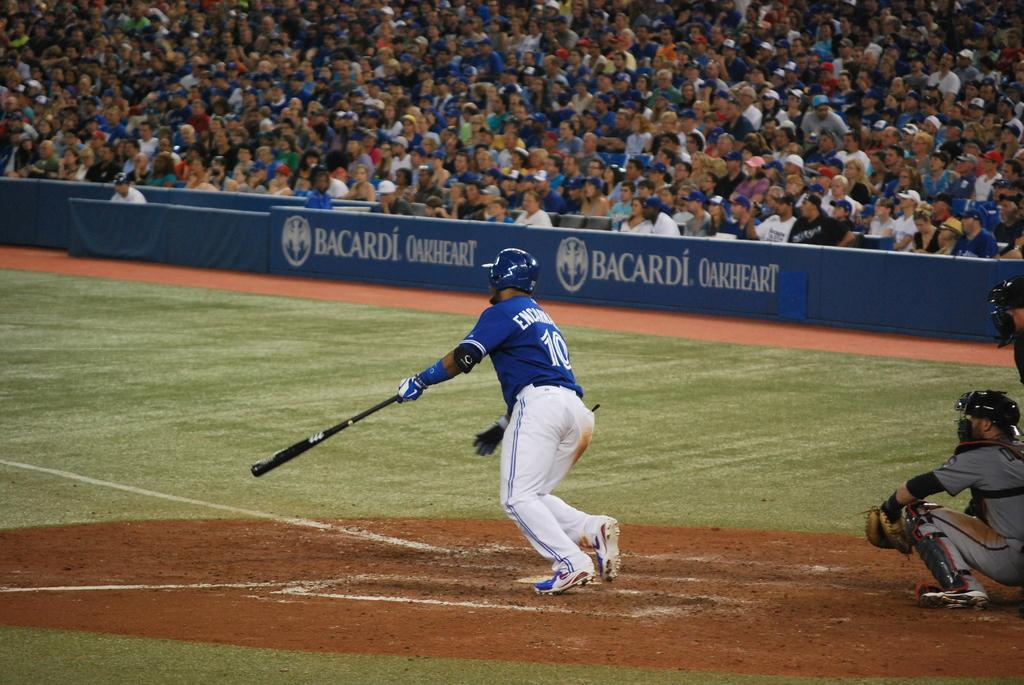<image>
Write a terse but informative summary of the picture. Bacardi Oakheart is advertised around this teams grounds. 